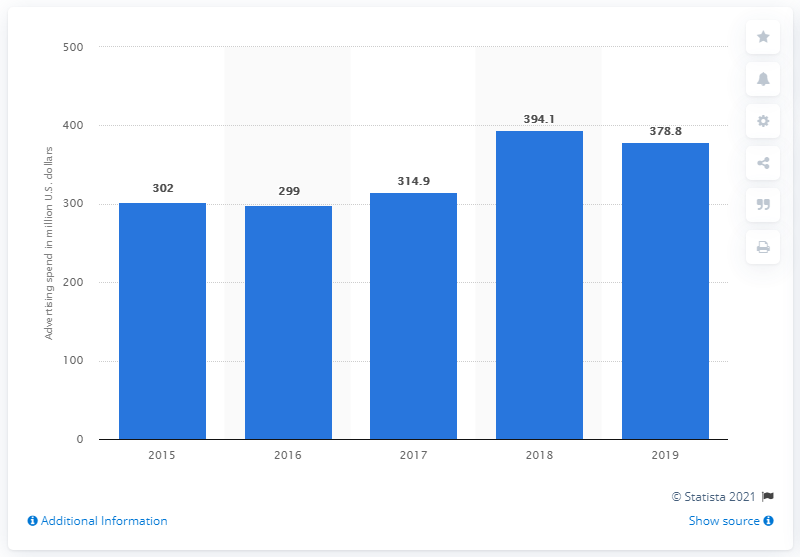List a handful of essential elements in this visual. In 2019, Tiffany and Co. spent approximately 378.8 million dollars on global advertising. 